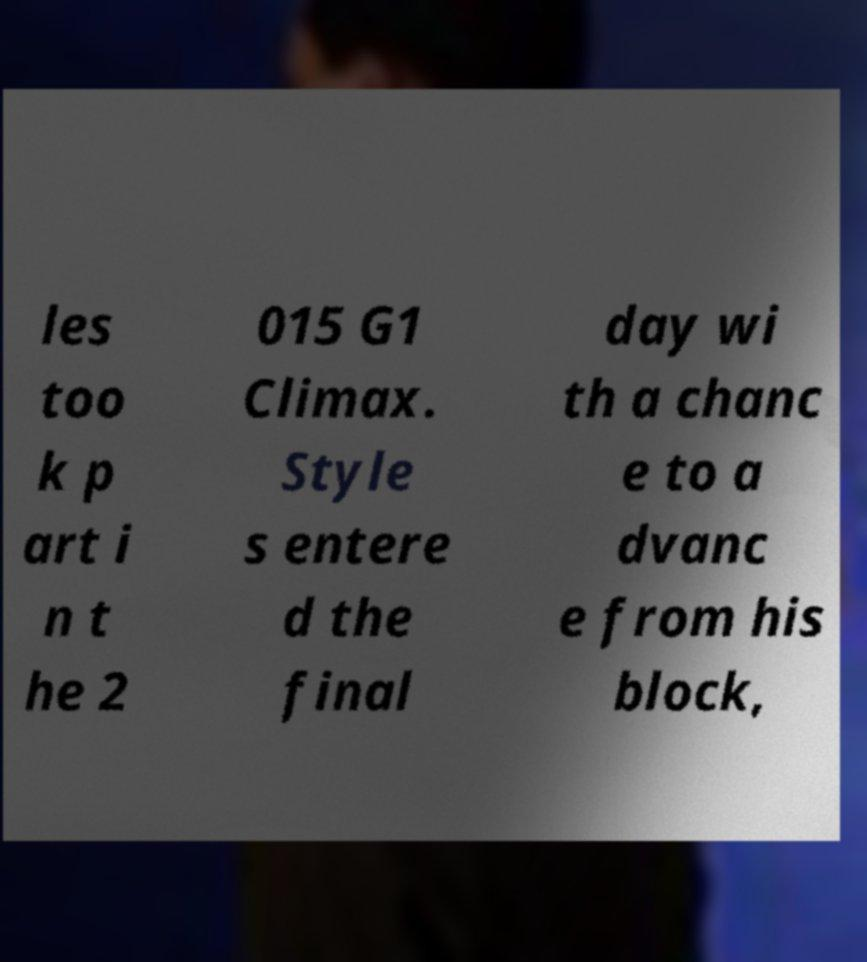Please read and relay the text visible in this image. What does it say? les too k p art i n t he 2 015 G1 Climax. Style s entere d the final day wi th a chanc e to a dvanc e from his block, 